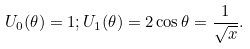Convert formula to latex. <formula><loc_0><loc_0><loc_500><loc_500>U _ { 0 } ( \theta ) = 1 ; U _ { 1 } ( \theta ) = 2 \cos \theta = \frac { 1 } { \sqrt { x } } .</formula> 